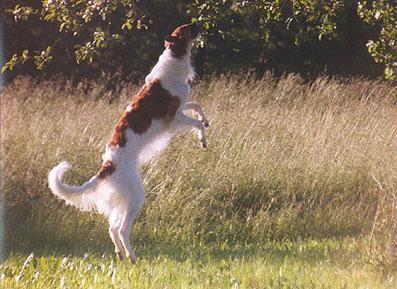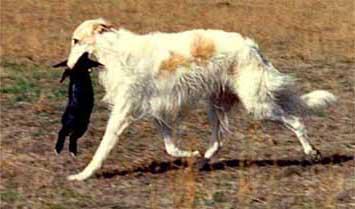The first image is the image on the left, the second image is the image on the right. Evaluate the accuracy of this statement regarding the images: "The dog in the image on the right is carrying something in its mouth.". Is it true? Answer yes or no. Yes. The first image is the image on the left, the second image is the image on the right. Analyze the images presented: Is the assertion "A dog that is mostly orange and a dog that is mostly white are together in a field covered with snow." valid? Answer yes or no. No. 